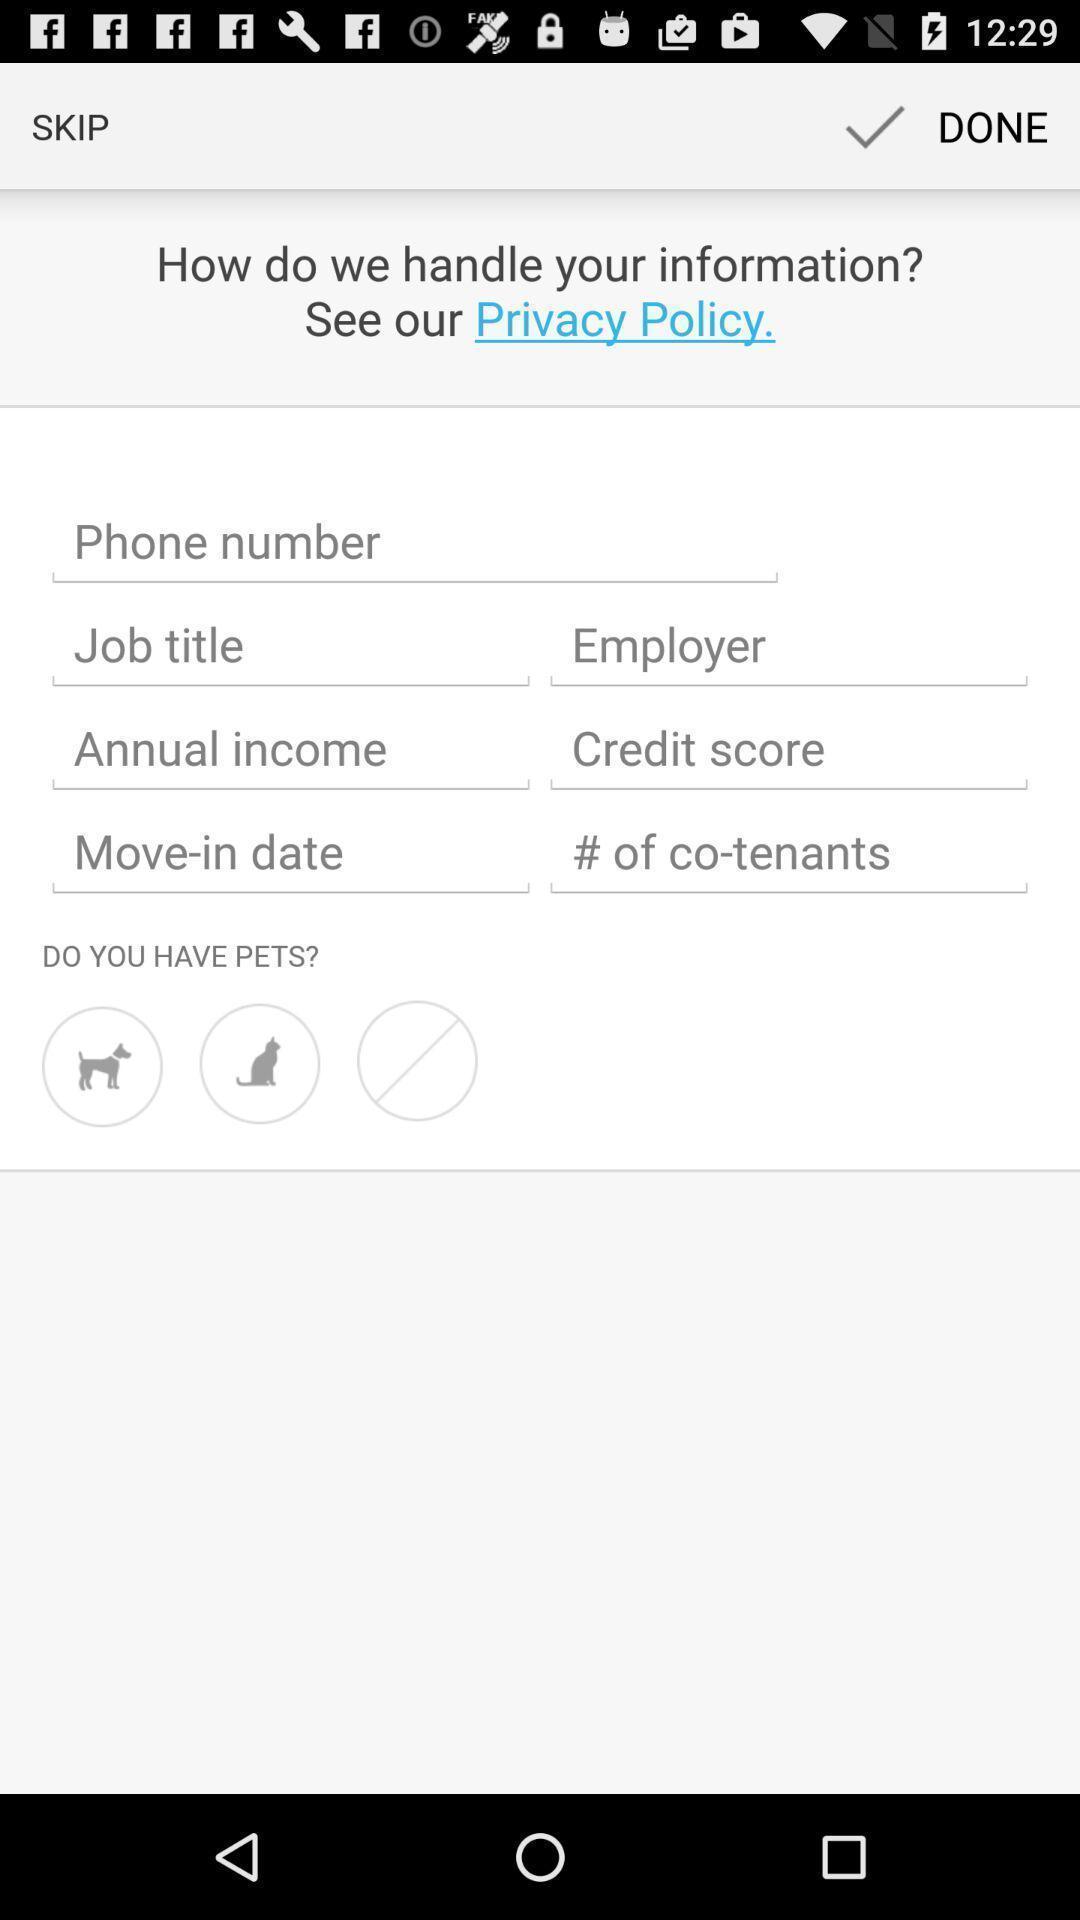Give me a narrative description of this picture. Page to handle privacy information safely. 